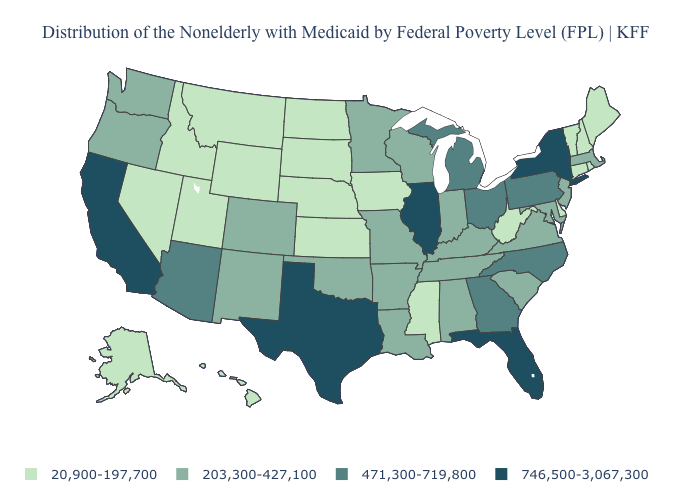What is the value of Tennessee?
Keep it brief. 203,300-427,100. Name the states that have a value in the range 203,300-427,100?
Keep it brief. Alabama, Arkansas, Colorado, Indiana, Kentucky, Louisiana, Maryland, Massachusetts, Minnesota, Missouri, New Jersey, New Mexico, Oklahoma, Oregon, South Carolina, Tennessee, Virginia, Washington, Wisconsin. Does Maine have the lowest value in the USA?
Short answer required. Yes. Name the states that have a value in the range 471,300-719,800?
Keep it brief. Arizona, Georgia, Michigan, North Carolina, Ohio, Pennsylvania. What is the highest value in the USA?
Give a very brief answer. 746,500-3,067,300. Does Delaware have a lower value than Idaho?
Give a very brief answer. No. What is the value of Kentucky?
Keep it brief. 203,300-427,100. What is the value of Georgia?
Give a very brief answer. 471,300-719,800. Name the states that have a value in the range 20,900-197,700?
Keep it brief. Alaska, Connecticut, Delaware, Hawaii, Idaho, Iowa, Kansas, Maine, Mississippi, Montana, Nebraska, Nevada, New Hampshire, North Dakota, Rhode Island, South Dakota, Utah, Vermont, West Virginia, Wyoming. Which states have the lowest value in the USA?
Concise answer only. Alaska, Connecticut, Delaware, Hawaii, Idaho, Iowa, Kansas, Maine, Mississippi, Montana, Nebraska, Nevada, New Hampshire, North Dakota, Rhode Island, South Dakota, Utah, Vermont, West Virginia, Wyoming. What is the value of Kentucky?
Keep it brief. 203,300-427,100. Does the map have missing data?
Quick response, please. No. What is the value of Minnesota?
Write a very short answer. 203,300-427,100. What is the lowest value in the MidWest?
Be succinct. 20,900-197,700. What is the value of Nebraska?
Answer briefly. 20,900-197,700. 